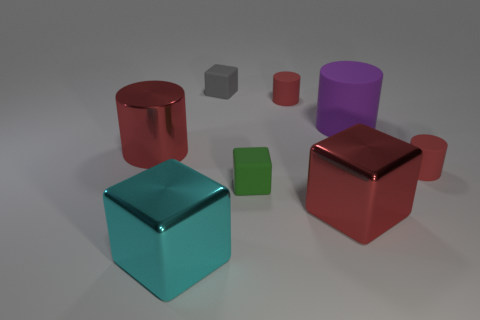Subtract all red cubes. How many cubes are left? 3 Subtract all red spheres. How many red cylinders are left? 3 Add 1 green objects. How many objects exist? 9 Subtract all purple cylinders. How many cylinders are left? 3 Subtract 1 green cubes. How many objects are left? 7 Subtract all cyan cubes. Subtract all blue cylinders. How many cubes are left? 3 Subtract all brown cylinders. Subtract all red shiny cubes. How many objects are left? 7 Add 7 cyan things. How many cyan things are left? 8 Add 3 tiny cubes. How many tiny cubes exist? 5 